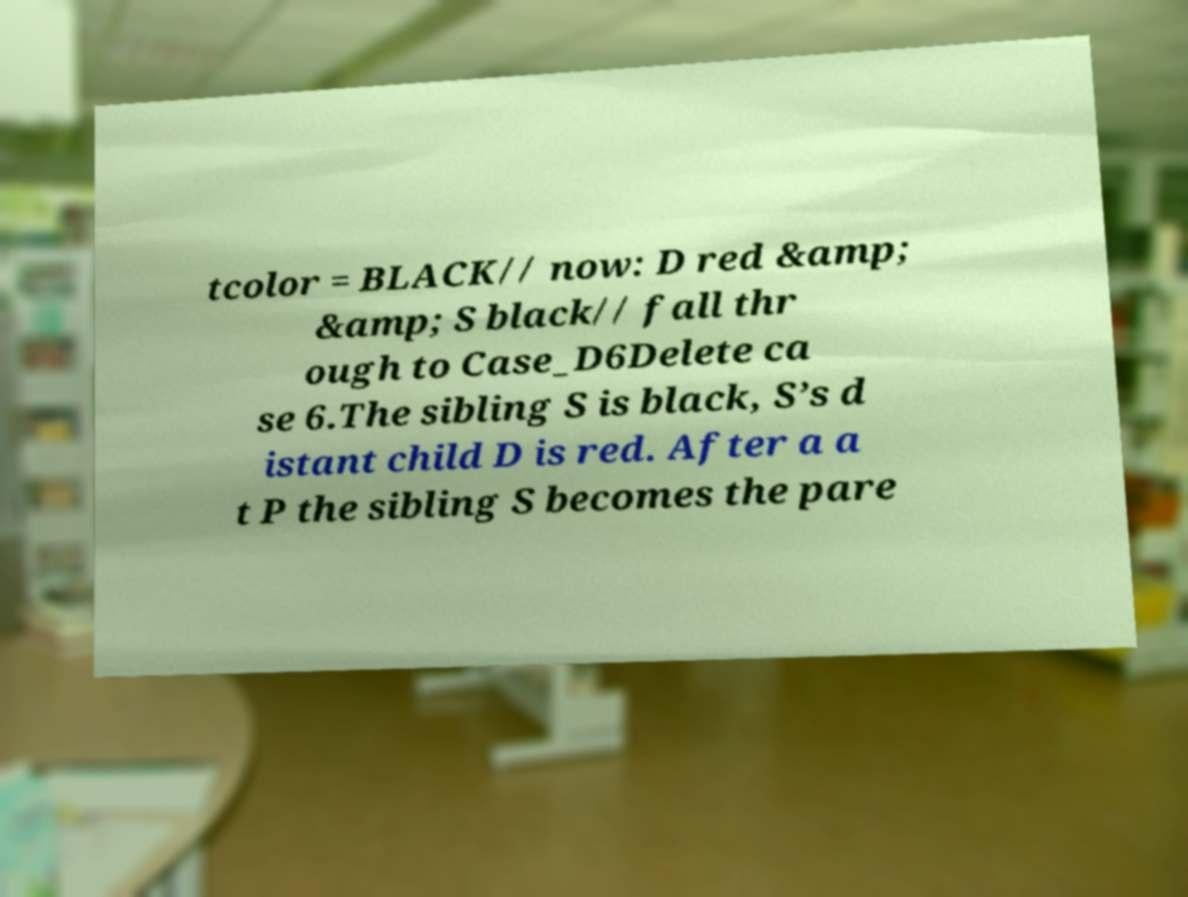I need the written content from this picture converted into text. Can you do that? tcolor = BLACK// now: D red &amp; &amp; S black// fall thr ough to Case_D6Delete ca se 6.The sibling S is black, S’s d istant child D is red. After a a t P the sibling S becomes the pare 